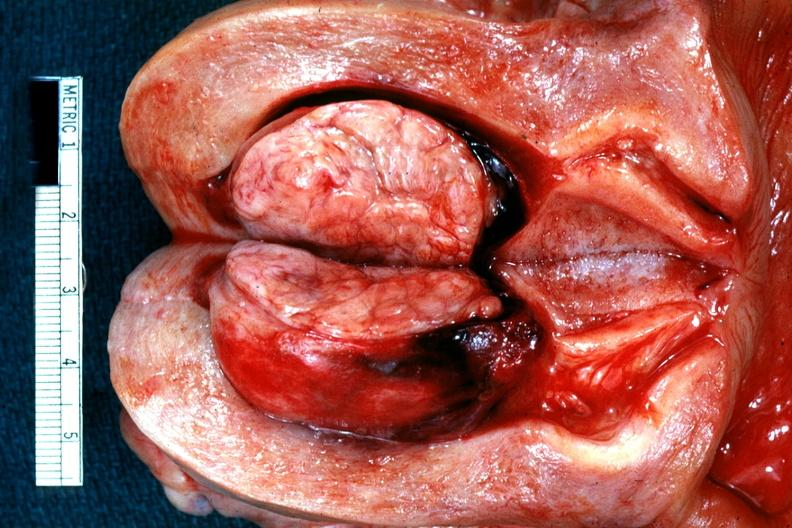s uterus present?
Answer the question using a single word or phrase. Yes 